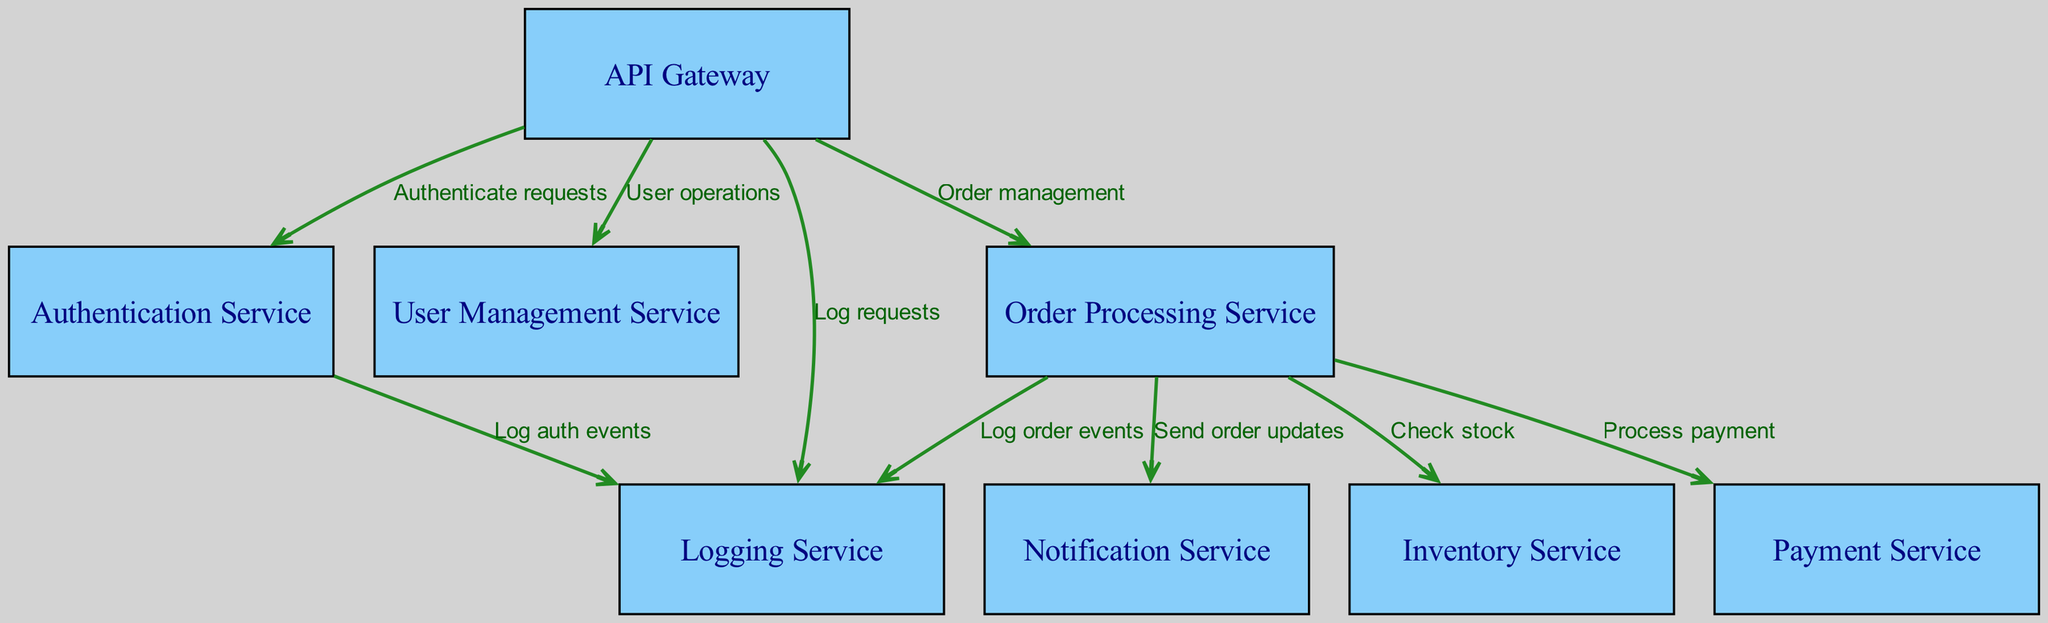What is the total number of nodes in the diagram? The diagram lists all the distinct microservices and components used, which are explicitly defined in the nodes section. Counting them gives a total of 8 nodes: API Gateway, Authentication Service, User Management Service, Order Processing Service, Inventory Service, Payment Service, Notification Service, Logging Service.
Answer: 8 Which service receives requests from the API Gateway for order management? The API Gateway directs requests related to order management specifically to the Order Processing Service as indicated by the direct edge labeled "Order management."
Answer: Order Processing Service How many edges are present in the directed graph? The edges represent the relationships between the services and actions taken. Each edge is counted from the edges section provided, where there are a total of 8 edges showing all the service interactions.
Answer: 8 What service does the Order Processing Service notify after processing an order? The diagram specifies that after the Order Processing Service completes an order, it sends updates to the Notification Service. This is shown by the directed edge labeled "Send order updates."
Answer: Notification Service What is the role of the Authentication Service in relation to the Logging Service? The Authentication Service directly logs authentication events to the Logging Service, as indicated by the labeled edge connecting these two services. This shows that any authentication activity is recorded for monitoring or auditing purposes.
Answer: Log auth events How many services does the API Gateway interact with? By analyzing the edges that emerge from the API Gateway node, it can be seen that there are 4 direct interactions: with the Authentication Service, User Management Service, Order Processing Service, and Logging Service. Counting these gives a total of 4 services.
Answer: 4 What does the Order Processing Service check before finalizing an order? According to the directed flow outlined in the edges, the Order Processing Service checks stock availability by directing a request to the Inventory Service, ensuring that inventory levels are sufficient before finalizing orders.
Answer: Check stock Which service processes payments following an order? The diagram shows a direct flow from the Order Processing Service to the Payment Service, indicating that the Payment Service is responsible for handling payment transactions for the orders placed.
Answer: Payment Service 